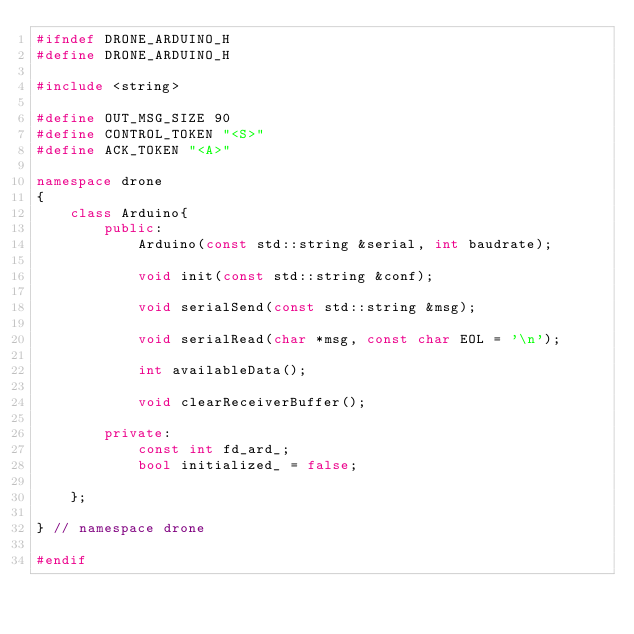Convert code to text. <code><loc_0><loc_0><loc_500><loc_500><_C++_>#ifndef DRONE_ARDUINO_H
#define DRONE_ARDUINO_H

#include <string>

#define OUT_MSG_SIZE 90
#define CONTROL_TOKEN "<S>"
#define ACK_TOKEN "<A>"

namespace drone
{
    class Arduino{
        public:
            Arduino(const std::string &serial, int baudrate);

            void init(const std::string &conf);

            void serialSend(const std::string &msg);

            void serialRead(char *msg, const char EOL = '\n');

            int availableData();

            void clearReceiverBuffer();

        private:
            const int fd_ard_;
            bool initialized_ = false;

    };

} // namespace drone

#endif</code> 